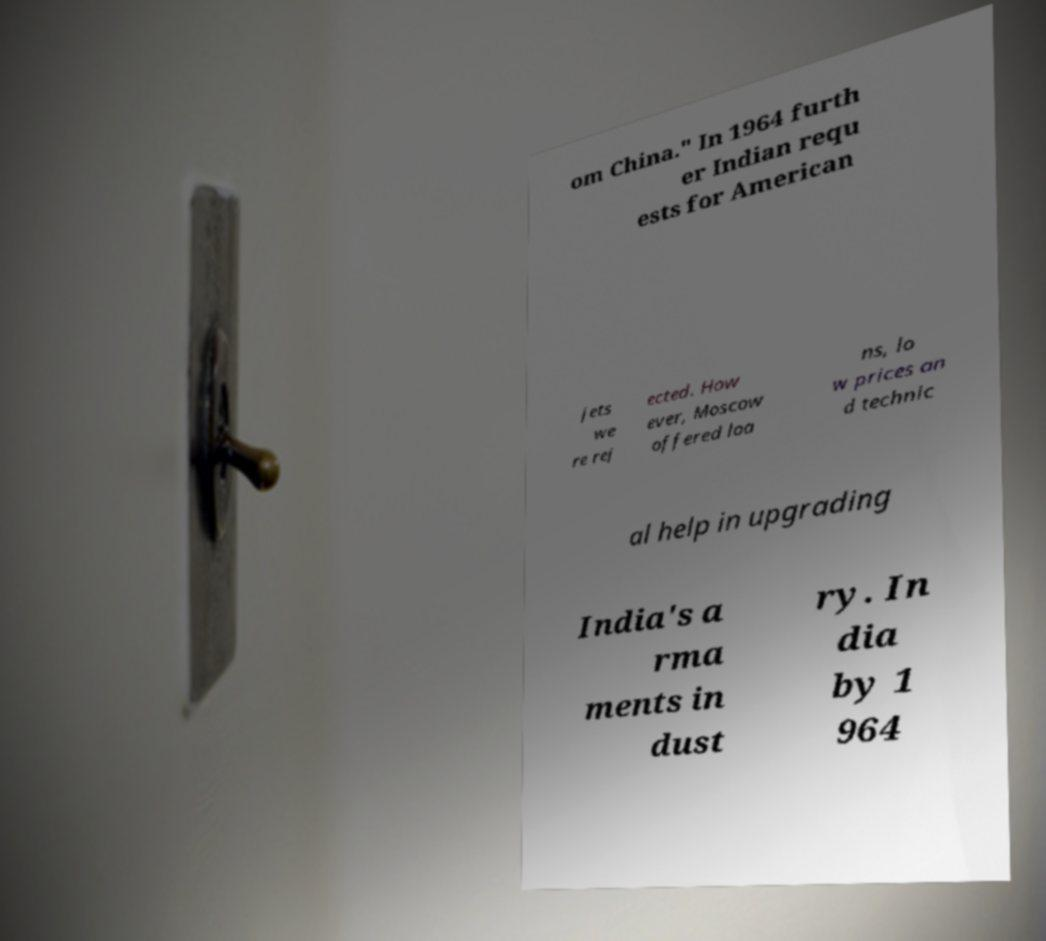Could you assist in decoding the text presented in this image and type it out clearly? om China." In 1964 furth er Indian requ ests for American jets we re rej ected. How ever, Moscow offered loa ns, lo w prices an d technic al help in upgrading India's a rma ments in dust ry. In dia by 1 964 